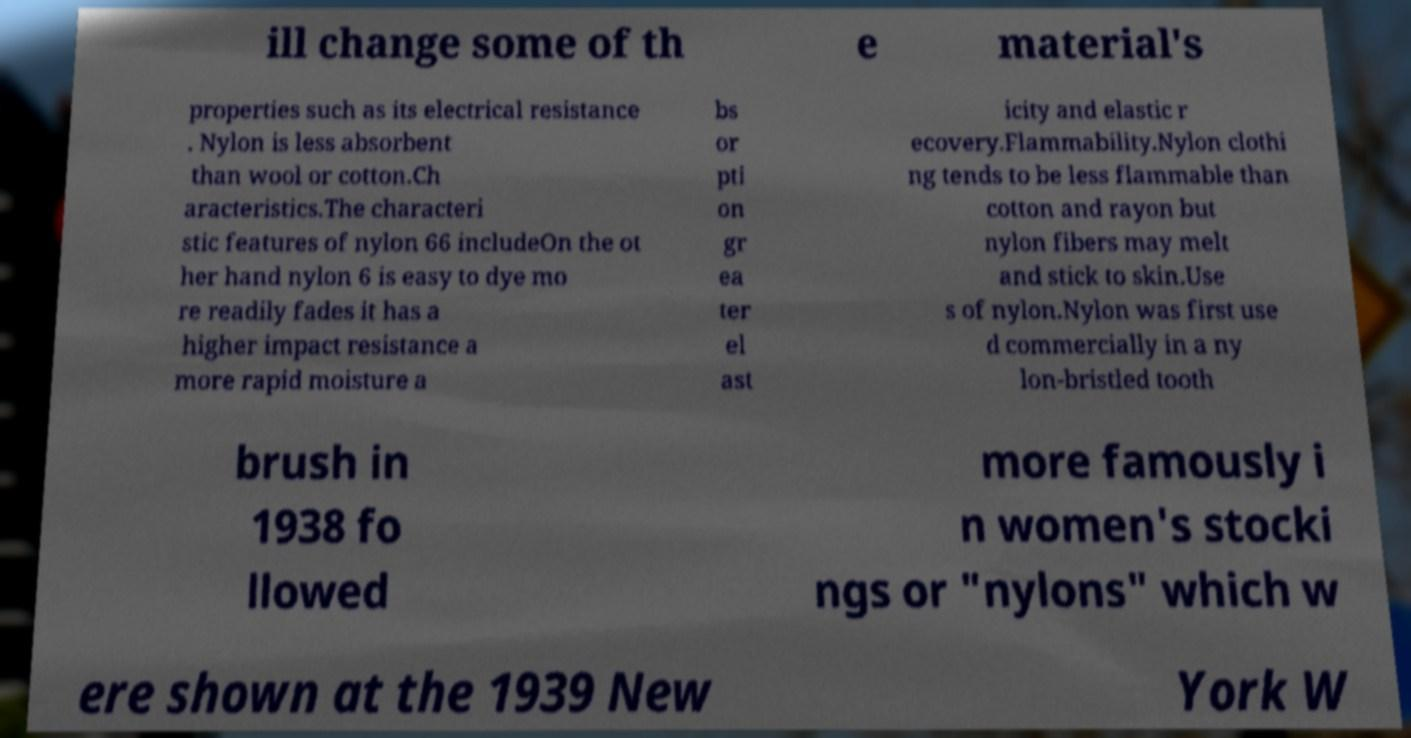There's text embedded in this image that I need extracted. Can you transcribe it verbatim? ill change some of th e material's properties such as its electrical resistance . Nylon is less absorbent than wool or cotton.Ch aracteristics.The characteri stic features of nylon 66 includeOn the ot her hand nylon 6 is easy to dye mo re readily fades it has a higher impact resistance a more rapid moisture a bs or pti on gr ea ter el ast icity and elastic r ecovery.Flammability.Nylon clothi ng tends to be less flammable than cotton and rayon but nylon fibers may melt and stick to skin.Use s of nylon.Nylon was first use d commercially in a ny lon-bristled tooth brush in 1938 fo llowed more famously i n women's stocki ngs or "nylons" which w ere shown at the 1939 New York W 